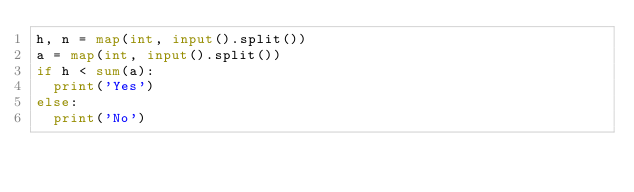<code> <loc_0><loc_0><loc_500><loc_500><_Python_>h, n = map(int, input().split())
a = map(int, input().split())
if h < sum(a):
  print('Yes')
else:
  print('No')</code> 